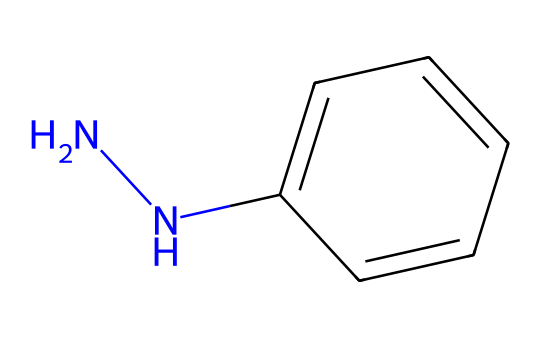What is the name of the chemical represented by the SMILES? The SMILES notation indicates the presence of a hydrazine functional group (NN) attached to a phenyl ring (c1ccccc1), leading to the identification of the compound as phenylhydrazine.
Answer: phenylhydrazine How many nitrogen atoms are in the structure? Analyzing the SMILES notation, we can see the "NN" indicating two nitrogen atoms connected to the carbon in the phenyl group, confirming there are two nitrogen atoms in the structure.
Answer: 2 What type of functional group is present in this chemical? The presence of the "NN" in the SMILES notation designates this chemical as containing a hydrazine functional group, which is characteristic of hydrazines.
Answer: hydrazine How many carbon atoms are present in the chemical structure? By counting the number of carbon atoms in the phenyl ring from the SMILES notation (c1ccccc1), we find there are 6 carbon atoms in this part of the structure.
Answer: 6 What type of bond connects the nitrogen atoms in phenylhydrazine? The "NN" in the SMILES notation represents a single bond between the two nitrogen atoms, characteristic of hydrazine compounds.
Answer: single bond What is the role of phenylhydrazine in advanced polymer coatings for race cars? Phenylhydrazine acts as a curing agent or hardener in advanced polymer coatings, which helps enhance the mechanical properties and chemical resistance of the coatings, improving durability in racing conditions.
Answer: curing agent Are the nitrogen atoms in phenylhydrazine primary or secondary? The nitrogen atoms in phenylhydrazine are classified as primary, as one nitrogen is attached to an alkyl (phenyl) group while the other is bonded to only hydrogen atoms.
Answer: primary 